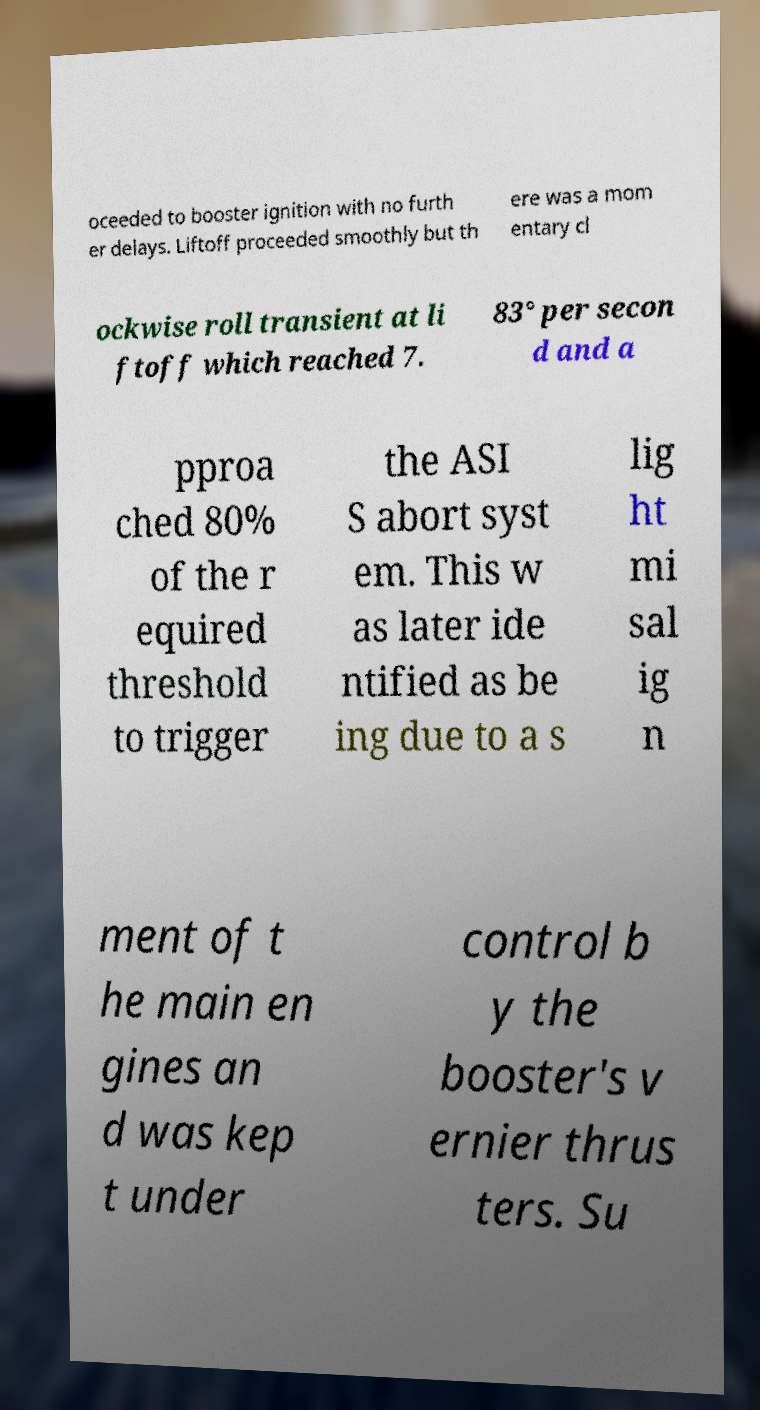Can you read and provide the text displayed in the image?This photo seems to have some interesting text. Can you extract and type it out for me? oceeded to booster ignition with no furth er delays. Liftoff proceeded smoothly but th ere was a mom entary cl ockwise roll transient at li ftoff which reached 7. 83° per secon d and a pproa ched 80% of the r equired threshold to trigger the ASI S abort syst em. This w as later ide ntified as be ing due to a s lig ht mi sal ig n ment of t he main en gines an d was kep t under control b y the booster's v ernier thrus ters. Su 